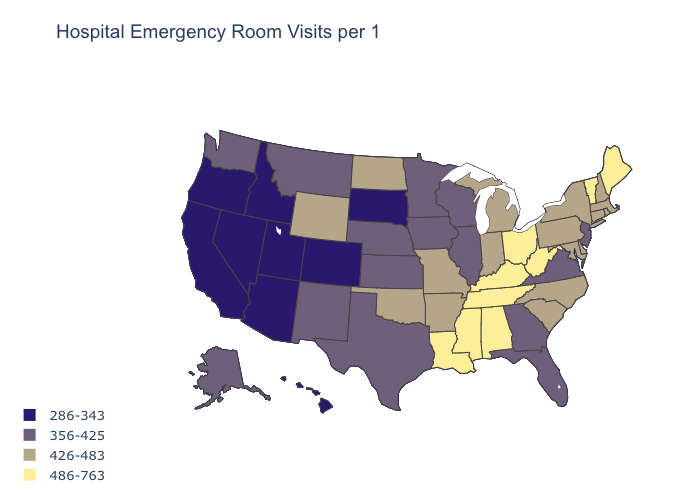Name the states that have a value in the range 426-483?
Be succinct. Arkansas, Connecticut, Delaware, Indiana, Maryland, Massachusetts, Michigan, Missouri, New Hampshire, New York, North Carolina, North Dakota, Oklahoma, Pennsylvania, Rhode Island, South Carolina, Wyoming. What is the value of Montana?
Quick response, please. 356-425. Does California have a higher value than Michigan?
Quick response, please. No. Does the map have missing data?
Keep it brief. No. What is the value of North Carolina?
Keep it brief. 426-483. Name the states that have a value in the range 286-343?
Write a very short answer. Arizona, California, Colorado, Hawaii, Idaho, Nevada, Oregon, South Dakota, Utah. What is the value of Maine?
Write a very short answer. 486-763. Does Alabama have the same value as Mississippi?
Write a very short answer. Yes. What is the value of Arizona?
Write a very short answer. 286-343. Name the states that have a value in the range 286-343?
Short answer required. Arizona, California, Colorado, Hawaii, Idaho, Nevada, Oregon, South Dakota, Utah. Which states hav the highest value in the South?
Short answer required. Alabama, Kentucky, Louisiana, Mississippi, Tennessee, West Virginia. Does Oregon have the lowest value in the West?
Be succinct. Yes. Name the states that have a value in the range 356-425?
Be succinct. Alaska, Florida, Georgia, Illinois, Iowa, Kansas, Minnesota, Montana, Nebraska, New Jersey, New Mexico, Texas, Virginia, Washington, Wisconsin. Which states have the highest value in the USA?
Quick response, please. Alabama, Kentucky, Louisiana, Maine, Mississippi, Ohio, Tennessee, Vermont, West Virginia. 